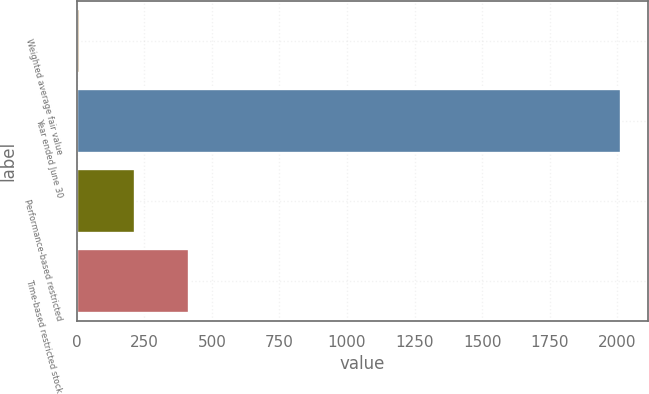Convert chart to OTSL. <chart><loc_0><loc_0><loc_500><loc_500><bar_chart><fcel>Weighted average fair value<fcel>Year ended June 30<fcel>Performance-based restricted<fcel>Time-based restricted stock<nl><fcel>13.53<fcel>2014<fcel>213.58<fcel>413.63<nl></chart> 